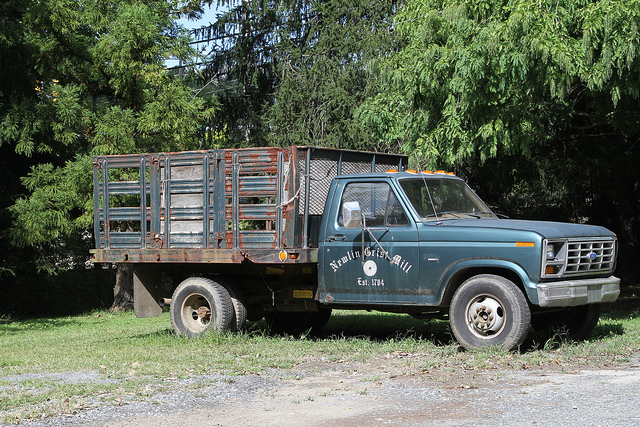Extract all visible text content from this image. Nemlin Crist Mill Est. 1784 